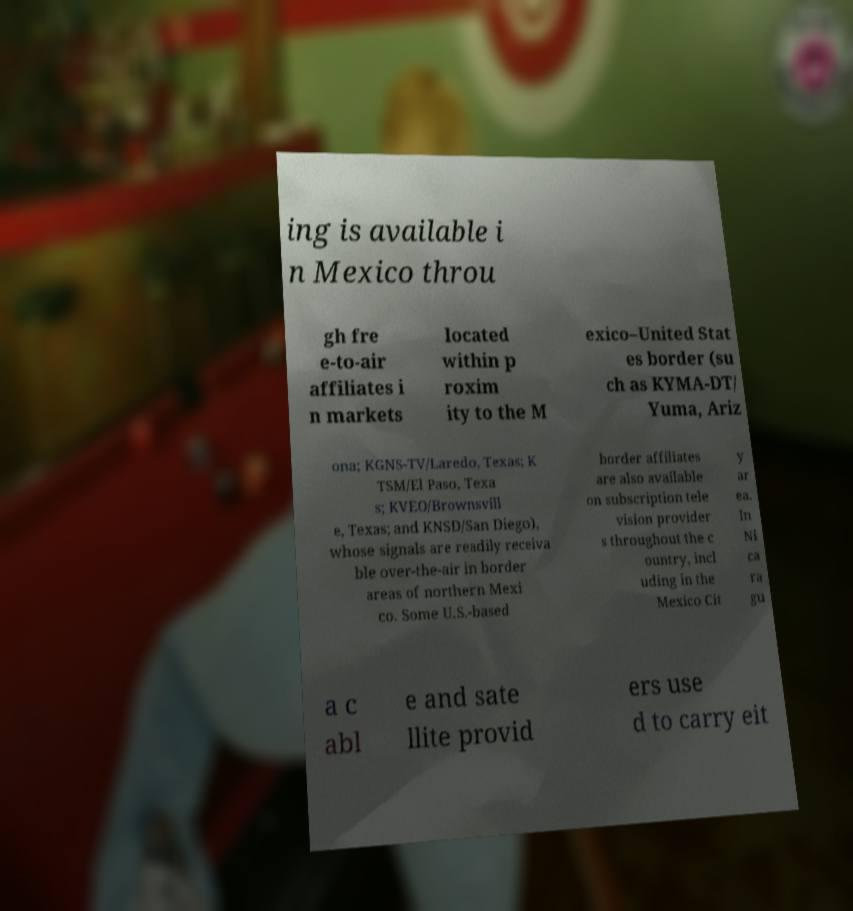Could you extract and type out the text from this image? ing is available i n Mexico throu gh fre e-to-air affiliates i n markets located within p roxim ity to the M exico–United Stat es border (su ch as KYMA-DT/ Yuma, Ariz ona; KGNS-TV/Laredo, Texas; K TSM/El Paso, Texa s; KVEO/Brownsvill e, Texas; and KNSD/San Diego), whose signals are readily receiva ble over-the-air in border areas of northern Mexi co. Some U.S.-based border affiliates are also available on subscription tele vision provider s throughout the c ountry, incl uding in the Mexico Cit y ar ea. In Ni ca ra gu a c abl e and sate llite provid ers use d to carry eit 